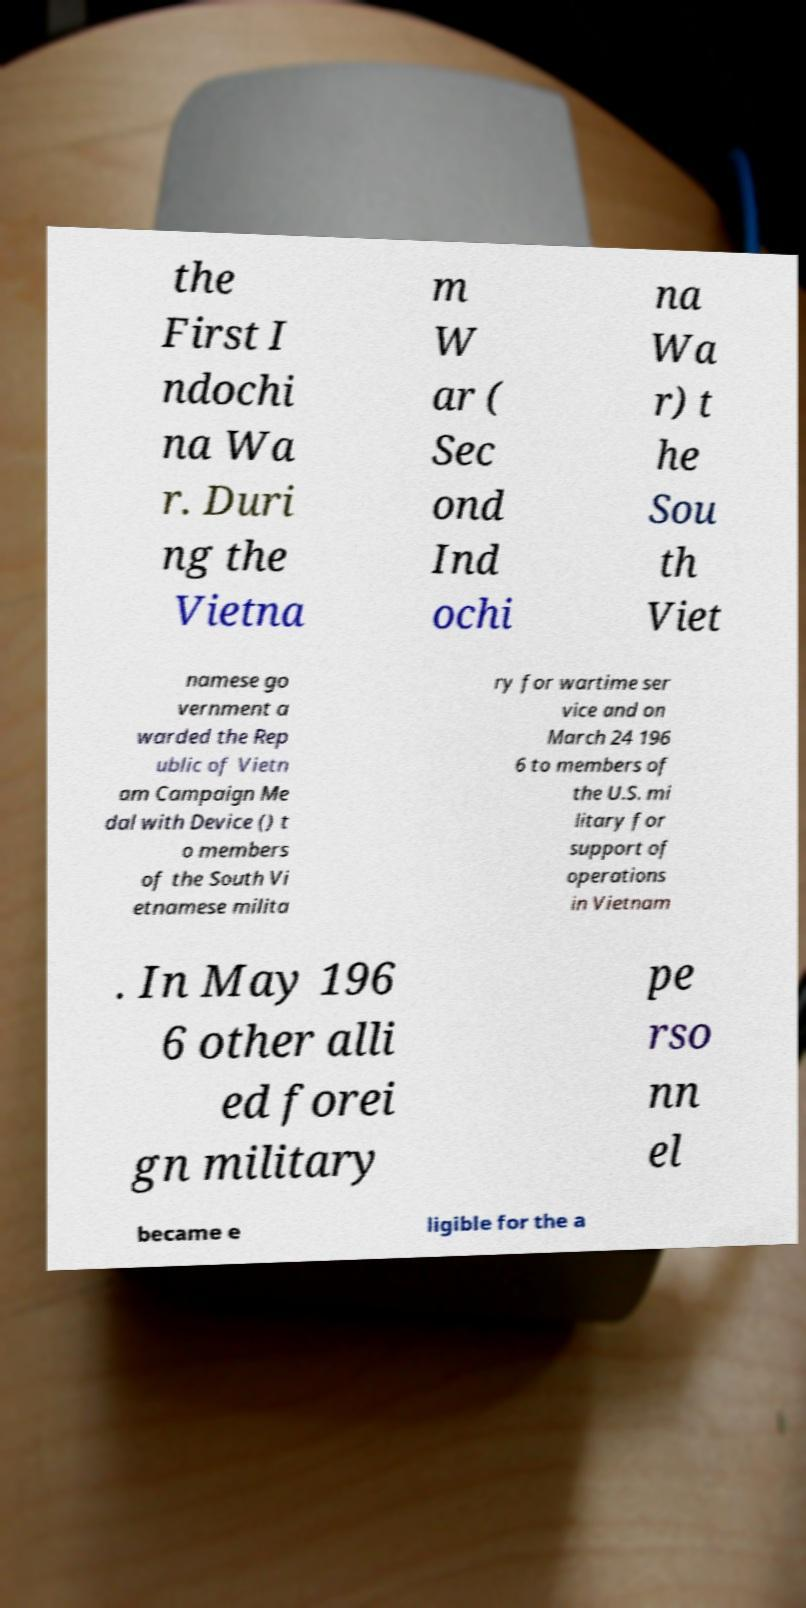Please read and relay the text visible in this image. What does it say? the First I ndochi na Wa r. Duri ng the Vietna m W ar ( Sec ond Ind ochi na Wa r) t he Sou th Viet namese go vernment a warded the Rep ublic of Vietn am Campaign Me dal with Device () t o members of the South Vi etnamese milita ry for wartime ser vice and on March 24 196 6 to members of the U.S. mi litary for support of operations in Vietnam . In May 196 6 other alli ed forei gn military pe rso nn el became e ligible for the a 